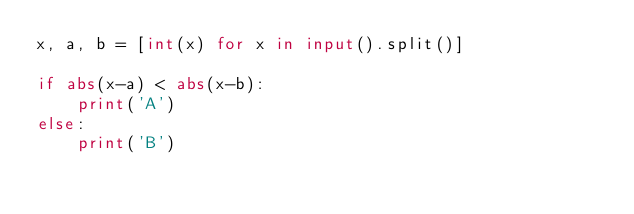<code> <loc_0><loc_0><loc_500><loc_500><_Python_>x, a, b = [int(x) for x in input().split()]

if abs(x-a) < abs(x-b):
    print('A')
else:
    print('B')
</code> 